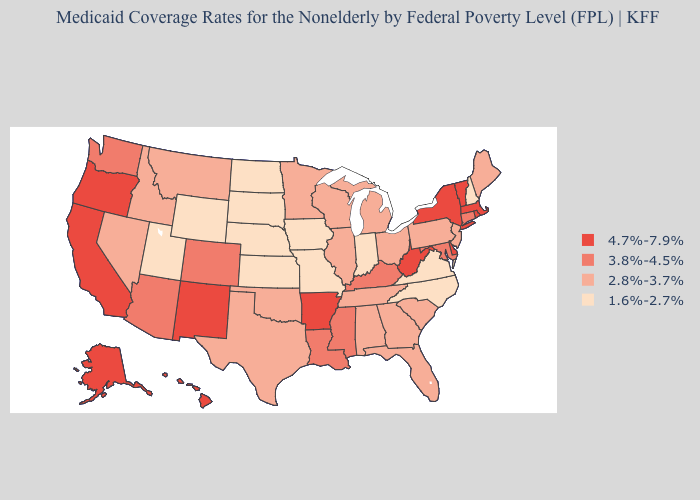Among the states that border Arkansas , does Missouri have the highest value?
Keep it brief. No. Does Washington have a higher value than Florida?
Short answer required. Yes. Does Arkansas have the highest value in the USA?
Short answer required. Yes. What is the value of Utah?
Keep it brief. 1.6%-2.7%. Which states have the lowest value in the MidWest?
Quick response, please. Indiana, Iowa, Kansas, Missouri, Nebraska, North Dakota, South Dakota. Name the states that have a value in the range 1.6%-2.7%?
Quick response, please. Indiana, Iowa, Kansas, Missouri, Nebraska, New Hampshire, North Carolina, North Dakota, South Dakota, Utah, Virginia, Wyoming. What is the highest value in the South ?
Be succinct. 4.7%-7.9%. Does Missouri have a lower value than West Virginia?
Concise answer only. Yes. What is the value of Massachusetts?
Short answer required. 4.7%-7.9%. Among the states that border Indiana , which have the lowest value?
Write a very short answer. Illinois, Michigan, Ohio. Which states have the highest value in the USA?
Write a very short answer. Alaska, Arkansas, California, Delaware, Hawaii, Massachusetts, New Mexico, New York, Oregon, Rhode Island, Vermont, West Virginia. Name the states that have a value in the range 2.8%-3.7%?
Give a very brief answer. Alabama, Florida, Georgia, Idaho, Illinois, Maine, Michigan, Minnesota, Montana, Nevada, New Jersey, Ohio, Oklahoma, Pennsylvania, South Carolina, Tennessee, Texas, Wisconsin. Among the states that border North Dakota , does Montana have the highest value?
Quick response, please. Yes. Among the states that border Oklahoma , which have the lowest value?
Be succinct. Kansas, Missouri. What is the highest value in the USA?
Write a very short answer. 4.7%-7.9%. 